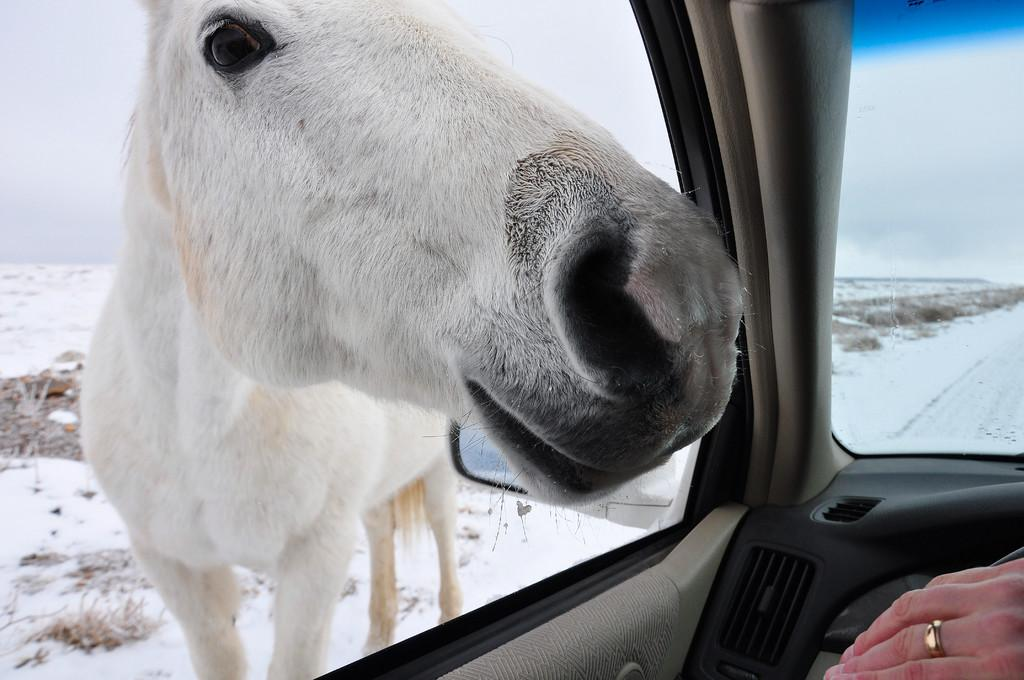What type of animal is in the image? There is a white color horse in the image. What other object can be seen on the right side of the image? There is a car on the right side of the image. Whose hand is visible in the image? A person's hand is visible in the image. What can be seen in the background of the image? There is sky and snow visible in the background of the image. What observation can be made about the brother's example in the image? There is no reference to a brother or an example in the image. 